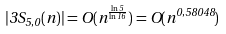<formula> <loc_0><loc_0><loc_500><loc_500>| 3 S _ { 5 , 0 } ( n ) | = O ( n ^ { \frac { \ln 5 } { \ln 1 6 } } ) = O ( n ^ { 0 , 5 8 0 4 8 } )</formula> 